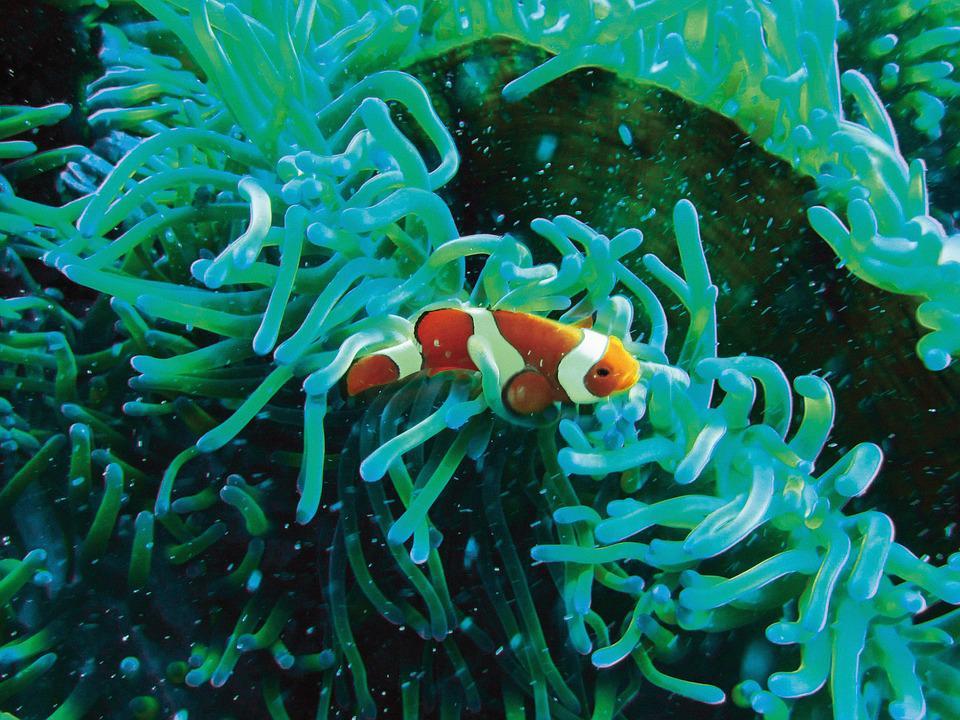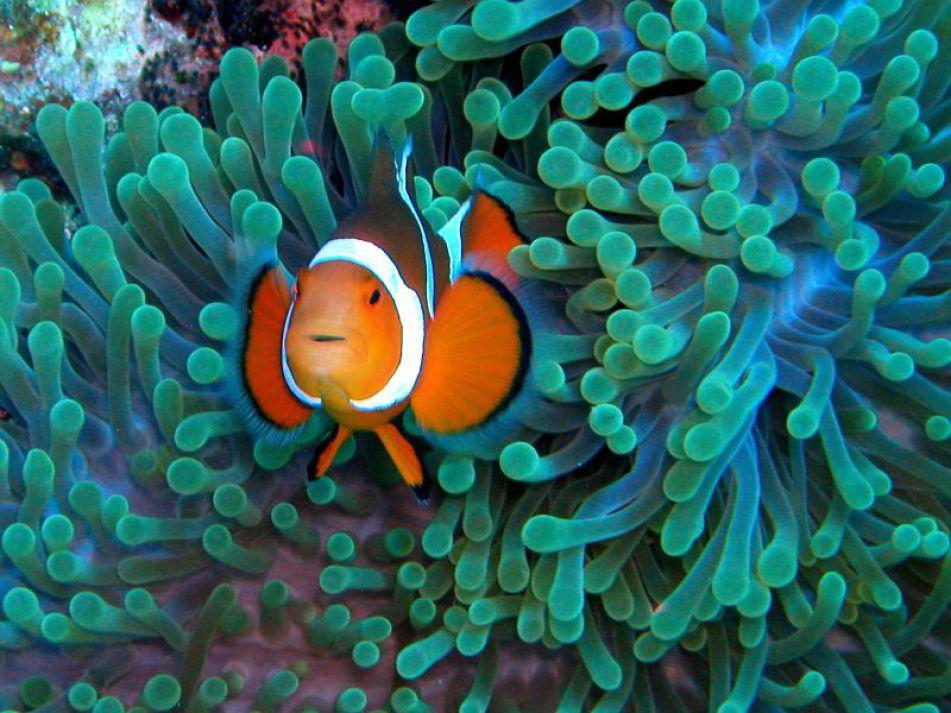The first image is the image on the left, the second image is the image on the right. Assess this claim about the two images: "Exactly two clown fish swim through anemone tendrils in one image.". Correct or not? Answer yes or no. No. 